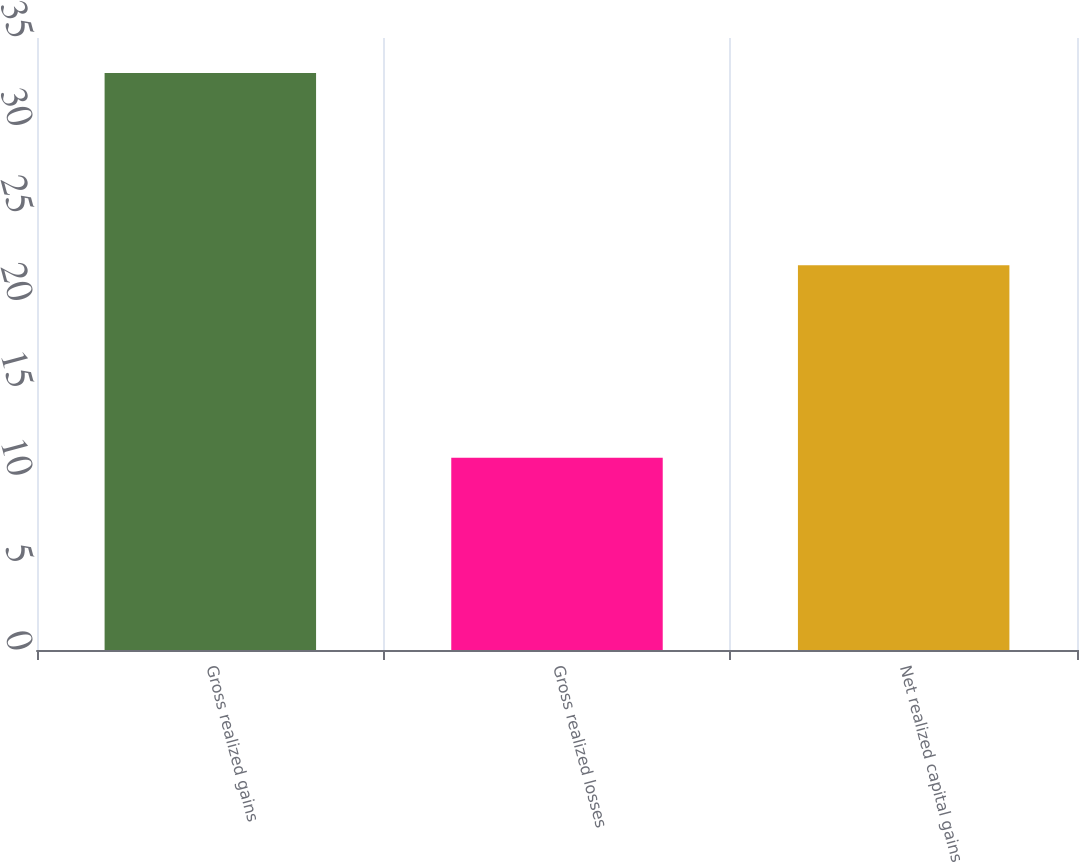Convert chart to OTSL. <chart><loc_0><loc_0><loc_500><loc_500><bar_chart><fcel>Gross realized gains<fcel>Gross realized losses<fcel>Net realized capital gains<nl><fcel>33<fcel>11<fcel>22<nl></chart> 